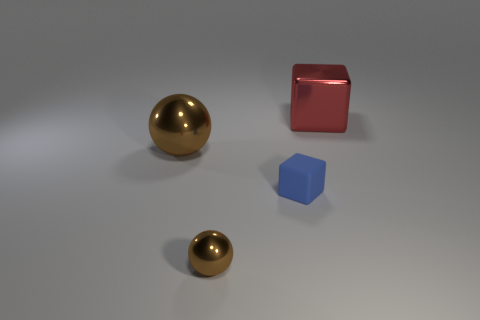Add 2 big shiny balls. How many objects exist? 6 Subtract 0 blue spheres. How many objects are left? 4 Subtract all purple blocks. Subtract all blue cylinders. How many blocks are left? 2 Subtract all small brown shiny things. Subtract all tiny red matte objects. How many objects are left? 3 Add 3 small blue things. How many small blue things are left? 4 Add 4 tiny objects. How many tiny objects exist? 6 